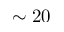<formula> <loc_0><loc_0><loc_500><loc_500>\sim 2 0</formula> 